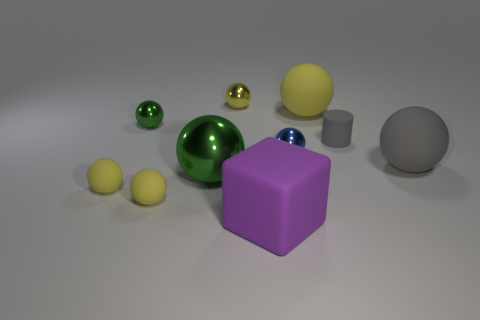How many things are large green metal balls or rubber things?
Your response must be concise. 7. Is there any other thing that has the same shape as the purple thing?
Make the answer very short. No. There is a tiny thing that is to the right of the yellow object that is on the right side of the large purple matte object; what is its shape?
Give a very brief answer. Cylinder. What shape is the large purple object that is made of the same material as the gray sphere?
Your answer should be very brief. Cube. There is a ball on the right side of the large sphere behind the small green thing; what size is it?
Your answer should be very brief. Large. What is the shape of the small green metal thing?
Make the answer very short. Sphere. How many small objects are shiny spheres or blue metallic balls?
Your answer should be very brief. 3. What size is the gray matte object that is the same shape as the blue metal thing?
Your response must be concise. Large. How many large things are both on the right side of the matte cylinder and in front of the large green metallic ball?
Ensure brevity in your answer.  0. Do the small yellow metal object and the big object left of the yellow metallic thing have the same shape?
Ensure brevity in your answer.  Yes. 